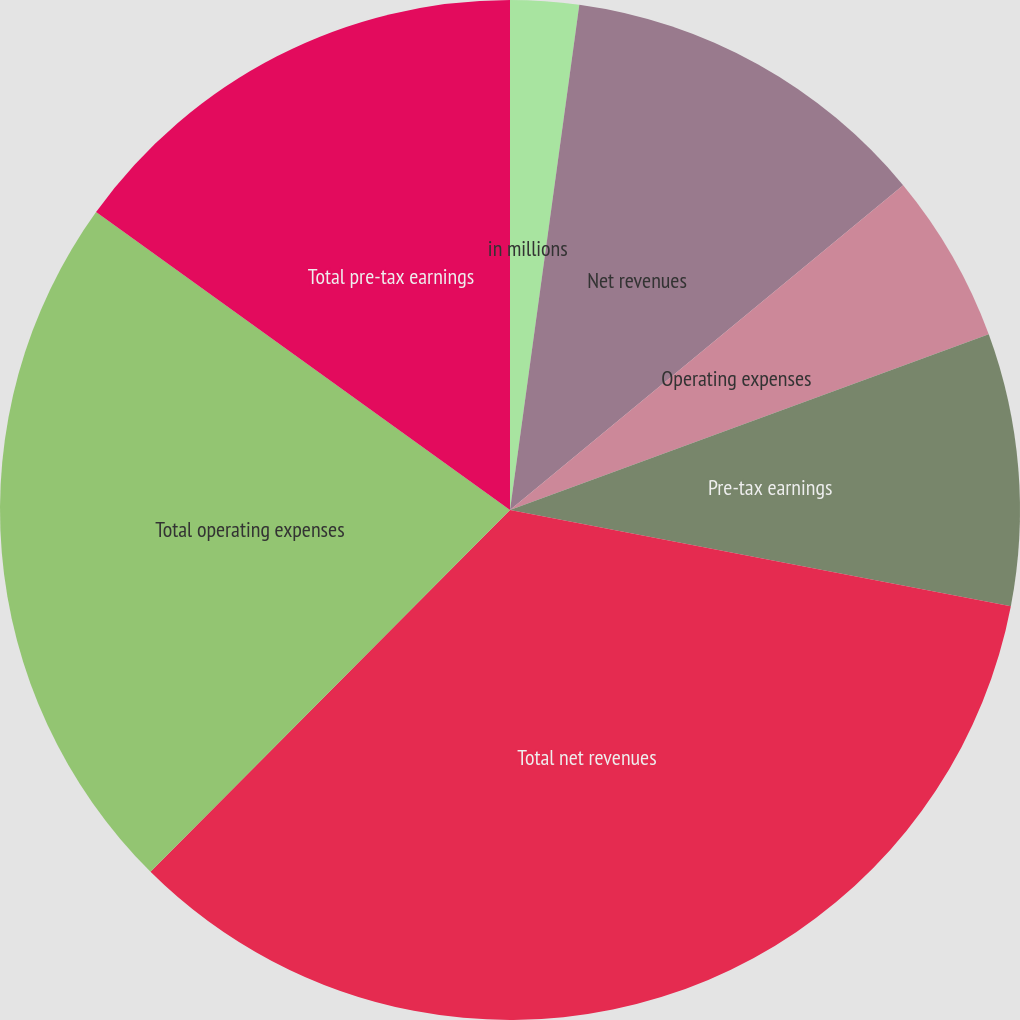Convert chart to OTSL. <chart><loc_0><loc_0><loc_500><loc_500><pie_chart><fcel>in millions<fcel>Net revenues<fcel>Operating expenses<fcel>Pre-tax earnings<fcel>Total net revenues<fcel>Total operating expenses<fcel>Total pre-tax earnings<nl><fcel>2.17%<fcel>11.84%<fcel>5.39%<fcel>8.62%<fcel>34.43%<fcel>22.48%<fcel>15.07%<nl></chart> 